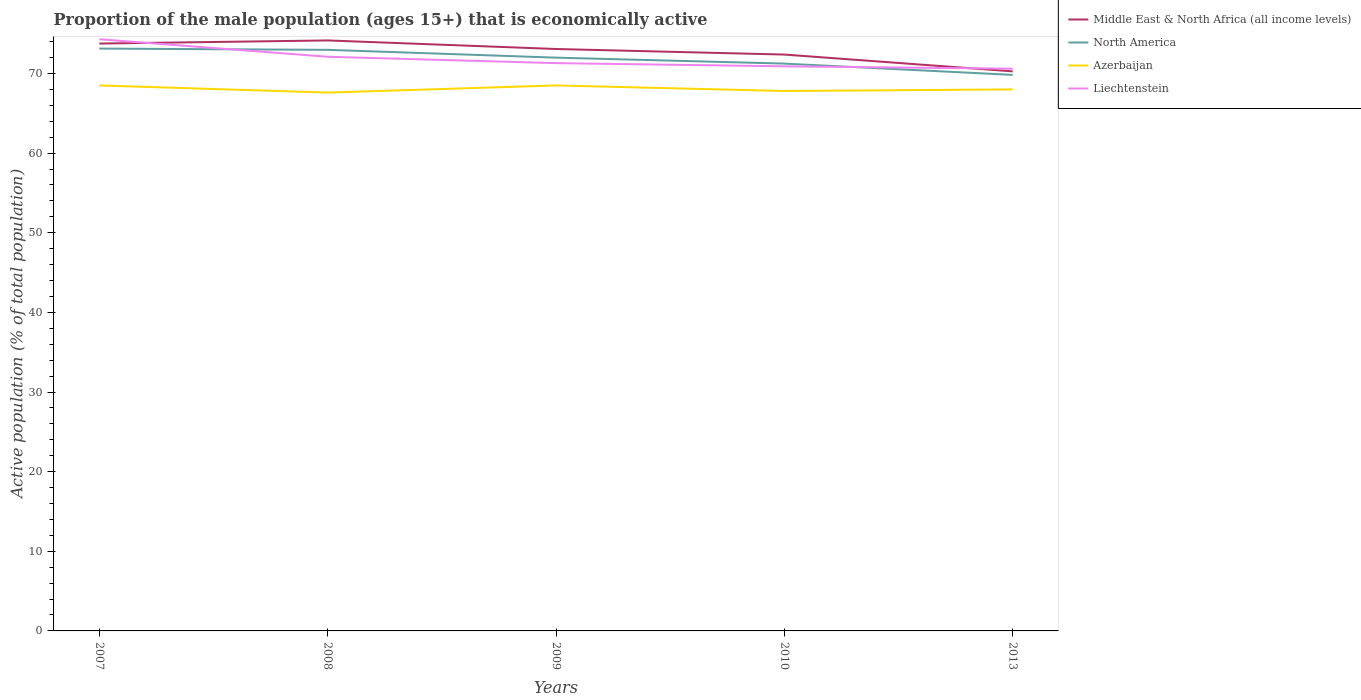Across all years, what is the maximum proportion of the male population that is economically active in Liechtenstein?
Ensure brevity in your answer.  70.6. What is the total proportion of the male population that is economically active in North America in the graph?
Ensure brevity in your answer.  0.75. What is the difference between the highest and the second highest proportion of the male population that is economically active in Liechtenstein?
Offer a terse response. 3.7. How many lines are there?
Provide a succinct answer. 4. How many years are there in the graph?
Provide a short and direct response. 5. Are the values on the major ticks of Y-axis written in scientific E-notation?
Provide a succinct answer. No. Does the graph contain any zero values?
Your answer should be compact. No. Does the graph contain grids?
Your answer should be compact. No. Where does the legend appear in the graph?
Keep it short and to the point. Top right. What is the title of the graph?
Provide a succinct answer. Proportion of the male population (ages 15+) that is economically active. What is the label or title of the X-axis?
Your response must be concise. Years. What is the label or title of the Y-axis?
Offer a very short reply. Active population (% of total population). What is the Active population (% of total population) in Middle East & North Africa (all income levels) in 2007?
Offer a very short reply. 73.76. What is the Active population (% of total population) of North America in 2007?
Give a very brief answer. 73.13. What is the Active population (% of total population) in Azerbaijan in 2007?
Your answer should be compact. 68.5. What is the Active population (% of total population) in Liechtenstein in 2007?
Your answer should be very brief. 74.3. What is the Active population (% of total population) of Middle East & North Africa (all income levels) in 2008?
Keep it short and to the point. 74.15. What is the Active population (% of total population) in North America in 2008?
Keep it short and to the point. 72.97. What is the Active population (% of total population) of Azerbaijan in 2008?
Offer a terse response. 67.6. What is the Active population (% of total population) in Liechtenstein in 2008?
Ensure brevity in your answer.  72.1. What is the Active population (% of total population) of Middle East & North Africa (all income levels) in 2009?
Ensure brevity in your answer.  73.08. What is the Active population (% of total population) of North America in 2009?
Ensure brevity in your answer.  71.99. What is the Active population (% of total population) of Azerbaijan in 2009?
Ensure brevity in your answer.  68.5. What is the Active population (% of total population) of Liechtenstein in 2009?
Keep it short and to the point. 71.3. What is the Active population (% of total population) of Middle East & North Africa (all income levels) in 2010?
Provide a succinct answer. 72.38. What is the Active population (% of total population) in North America in 2010?
Offer a terse response. 71.24. What is the Active population (% of total population) of Azerbaijan in 2010?
Provide a succinct answer. 67.8. What is the Active population (% of total population) in Liechtenstein in 2010?
Ensure brevity in your answer.  70.9. What is the Active population (% of total population) in Middle East & North Africa (all income levels) in 2013?
Keep it short and to the point. 70.27. What is the Active population (% of total population) of North America in 2013?
Keep it short and to the point. 69.82. What is the Active population (% of total population) in Azerbaijan in 2013?
Keep it short and to the point. 68. What is the Active population (% of total population) in Liechtenstein in 2013?
Your response must be concise. 70.6. Across all years, what is the maximum Active population (% of total population) of Middle East & North Africa (all income levels)?
Provide a succinct answer. 74.15. Across all years, what is the maximum Active population (% of total population) in North America?
Ensure brevity in your answer.  73.13. Across all years, what is the maximum Active population (% of total population) of Azerbaijan?
Make the answer very short. 68.5. Across all years, what is the maximum Active population (% of total population) in Liechtenstein?
Offer a terse response. 74.3. Across all years, what is the minimum Active population (% of total population) of Middle East & North Africa (all income levels)?
Provide a succinct answer. 70.27. Across all years, what is the minimum Active population (% of total population) of North America?
Offer a very short reply. 69.82. Across all years, what is the minimum Active population (% of total population) in Azerbaijan?
Your response must be concise. 67.6. Across all years, what is the minimum Active population (% of total population) of Liechtenstein?
Provide a succinct answer. 70.6. What is the total Active population (% of total population) in Middle East & North Africa (all income levels) in the graph?
Your answer should be compact. 363.63. What is the total Active population (% of total population) of North America in the graph?
Provide a short and direct response. 359.15. What is the total Active population (% of total population) of Azerbaijan in the graph?
Provide a succinct answer. 340.4. What is the total Active population (% of total population) of Liechtenstein in the graph?
Your answer should be very brief. 359.2. What is the difference between the Active population (% of total population) of Middle East & North Africa (all income levels) in 2007 and that in 2008?
Your response must be concise. -0.39. What is the difference between the Active population (% of total population) in North America in 2007 and that in 2008?
Provide a succinct answer. 0.16. What is the difference between the Active population (% of total population) in Liechtenstein in 2007 and that in 2008?
Provide a short and direct response. 2.2. What is the difference between the Active population (% of total population) of Middle East & North Africa (all income levels) in 2007 and that in 2009?
Your answer should be compact. 0.68. What is the difference between the Active population (% of total population) of North America in 2007 and that in 2009?
Provide a succinct answer. 1.14. What is the difference between the Active population (% of total population) of Middle East & North Africa (all income levels) in 2007 and that in 2010?
Offer a very short reply. 1.38. What is the difference between the Active population (% of total population) of North America in 2007 and that in 2010?
Your answer should be compact. 1.89. What is the difference between the Active population (% of total population) in Azerbaijan in 2007 and that in 2010?
Provide a short and direct response. 0.7. What is the difference between the Active population (% of total population) of Liechtenstein in 2007 and that in 2010?
Keep it short and to the point. 3.4. What is the difference between the Active population (% of total population) of Middle East & North Africa (all income levels) in 2007 and that in 2013?
Provide a short and direct response. 3.49. What is the difference between the Active population (% of total population) of North America in 2007 and that in 2013?
Offer a terse response. 3.3. What is the difference between the Active population (% of total population) in Middle East & North Africa (all income levels) in 2008 and that in 2009?
Make the answer very short. 1.08. What is the difference between the Active population (% of total population) of North America in 2008 and that in 2009?
Offer a very short reply. 0.98. What is the difference between the Active population (% of total population) in Azerbaijan in 2008 and that in 2009?
Your response must be concise. -0.9. What is the difference between the Active population (% of total population) in Liechtenstein in 2008 and that in 2009?
Give a very brief answer. 0.8. What is the difference between the Active population (% of total population) of Middle East & North Africa (all income levels) in 2008 and that in 2010?
Provide a short and direct response. 1.77. What is the difference between the Active population (% of total population) of North America in 2008 and that in 2010?
Provide a short and direct response. 1.73. What is the difference between the Active population (% of total population) in Azerbaijan in 2008 and that in 2010?
Your answer should be very brief. -0.2. What is the difference between the Active population (% of total population) in Liechtenstein in 2008 and that in 2010?
Offer a terse response. 1.2. What is the difference between the Active population (% of total population) of Middle East & North Africa (all income levels) in 2008 and that in 2013?
Make the answer very short. 3.88. What is the difference between the Active population (% of total population) in North America in 2008 and that in 2013?
Your answer should be very brief. 3.15. What is the difference between the Active population (% of total population) in Azerbaijan in 2008 and that in 2013?
Provide a short and direct response. -0.4. What is the difference between the Active population (% of total population) of Liechtenstein in 2008 and that in 2013?
Offer a terse response. 1.5. What is the difference between the Active population (% of total population) of Middle East & North Africa (all income levels) in 2009 and that in 2010?
Your answer should be compact. 0.7. What is the difference between the Active population (% of total population) in North America in 2009 and that in 2010?
Your answer should be very brief. 0.75. What is the difference between the Active population (% of total population) of Azerbaijan in 2009 and that in 2010?
Offer a terse response. 0.7. What is the difference between the Active population (% of total population) of Liechtenstein in 2009 and that in 2010?
Give a very brief answer. 0.4. What is the difference between the Active population (% of total population) of Middle East & North Africa (all income levels) in 2009 and that in 2013?
Ensure brevity in your answer.  2.81. What is the difference between the Active population (% of total population) of North America in 2009 and that in 2013?
Ensure brevity in your answer.  2.17. What is the difference between the Active population (% of total population) of Azerbaijan in 2009 and that in 2013?
Give a very brief answer. 0.5. What is the difference between the Active population (% of total population) of Middle East & North Africa (all income levels) in 2010 and that in 2013?
Your response must be concise. 2.11. What is the difference between the Active population (% of total population) in North America in 2010 and that in 2013?
Provide a short and direct response. 1.42. What is the difference between the Active population (% of total population) in Middle East & North Africa (all income levels) in 2007 and the Active population (% of total population) in North America in 2008?
Make the answer very short. 0.79. What is the difference between the Active population (% of total population) of Middle East & North Africa (all income levels) in 2007 and the Active population (% of total population) of Azerbaijan in 2008?
Your answer should be very brief. 6.16. What is the difference between the Active population (% of total population) in Middle East & North Africa (all income levels) in 2007 and the Active population (% of total population) in Liechtenstein in 2008?
Your response must be concise. 1.66. What is the difference between the Active population (% of total population) of North America in 2007 and the Active population (% of total population) of Azerbaijan in 2008?
Your response must be concise. 5.53. What is the difference between the Active population (% of total population) in North America in 2007 and the Active population (% of total population) in Liechtenstein in 2008?
Make the answer very short. 1.03. What is the difference between the Active population (% of total population) in Azerbaijan in 2007 and the Active population (% of total population) in Liechtenstein in 2008?
Offer a terse response. -3.6. What is the difference between the Active population (% of total population) in Middle East & North Africa (all income levels) in 2007 and the Active population (% of total population) in North America in 2009?
Provide a short and direct response. 1.77. What is the difference between the Active population (% of total population) in Middle East & North Africa (all income levels) in 2007 and the Active population (% of total population) in Azerbaijan in 2009?
Offer a very short reply. 5.26. What is the difference between the Active population (% of total population) of Middle East & North Africa (all income levels) in 2007 and the Active population (% of total population) of Liechtenstein in 2009?
Your response must be concise. 2.46. What is the difference between the Active population (% of total population) of North America in 2007 and the Active population (% of total population) of Azerbaijan in 2009?
Make the answer very short. 4.63. What is the difference between the Active population (% of total population) of North America in 2007 and the Active population (% of total population) of Liechtenstein in 2009?
Offer a terse response. 1.83. What is the difference between the Active population (% of total population) of Azerbaijan in 2007 and the Active population (% of total population) of Liechtenstein in 2009?
Make the answer very short. -2.8. What is the difference between the Active population (% of total population) of Middle East & North Africa (all income levels) in 2007 and the Active population (% of total population) of North America in 2010?
Offer a very short reply. 2.52. What is the difference between the Active population (% of total population) of Middle East & North Africa (all income levels) in 2007 and the Active population (% of total population) of Azerbaijan in 2010?
Offer a very short reply. 5.96. What is the difference between the Active population (% of total population) of Middle East & North Africa (all income levels) in 2007 and the Active population (% of total population) of Liechtenstein in 2010?
Your answer should be compact. 2.86. What is the difference between the Active population (% of total population) in North America in 2007 and the Active population (% of total population) in Azerbaijan in 2010?
Ensure brevity in your answer.  5.33. What is the difference between the Active population (% of total population) in North America in 2007 and the Active population (% of total population) in Liechtenstein in 2010?
Make the answer very short. 2.23. What is the difference between the Active population (% of total population) in Middle East & North Africa (all income levels) in 2007 and the Active population (% of total population) in North America in 2013?
Keep it short and to the point. 3.94. What is the difference between the Active population (% of total population) in Middle East & North Africa (all income levels) in 2007 and the Active population (% of total population) in Azerbaijan in 2013?
Keep it short and to the point. 5.76. What is the difference between the Active population (% of total population) of Middle East & North Africa (all income levels) in 2007 and the Active population (% of total population) of Liechtenstein in 2013?
Your answer should be very brief. 3.16. What is the difference between the Active population (% of total population) of North America in 2007 and the Active population (% of total population) of Azerbaijan in 2013?
Provide a short and direct response. 5.13. What is the difference between the Active population (% of total population) in North America in 2007 and the Active population (% of total population) in Liechtenstein in 2013?
Offer a very short reply. 2.53. What is the difference between the Active population (% of total population) in Middle East & North Africa (all income levels) in 2008 and the Active population (% of total population) in North America in 2009?
Provide a short and direct response. 2.16. What is the difference between the Active population (% of total population) of Middle East & North Africa (all income levels) in 2008 and the Active population (% of total population) of Azerbaijan in 2009?
Give a very brief answer. 5.65. What is the difference between the Active population (% of total population) in Middle East & North Africa (all income levels) in 2008 and the Active population (% of total population) in Liechtenstein in 2009?
Offer a terse response. 2.85. What is the difference between the Active population (% of total population) of North America in 2008 and the Active population (% of total population) of Azerbaijan in 2009?
Offer a terse response. 4.47. What is the difference between the Active population (% of total population) in North America in 2008 and the Active population (% of total population) in Liechtenstein in 2009?
Offer a terse response. 1.67. What is the difference between the Active population (% of total population) in Middle East & North Africa (all income levels) in 2008 and the Active population (% of total population) in North America in 2010?
Provide a succinct answer. 2.91. What is the difference between the Active population (% of total population) of Middle East & North Africa (all income levels) in 2008 and the Active population (% of total population) of Azerbaijan in 2010?
Give a very brief answer. 6.35. What is the difference between the Active population (% of total population) in Middle East & North Africa (all income levels) in 2008 and the Active population (% of total population) in Liechtenstein in 2010?
Your answer should be compact. 3.25. What is the difference between the Active population (% of total population) of North America in 2008 and the Active population (% of total population) of Azerbaijan in 2010?
Make the answer very short. 5.17. What is the difference between the Active population (% of total population) in North America in 2008 and the Active population (% of total population) in Liechtenstein in 2010?
Give a very brief answer. 2.07. What is the difference between the Active population (% of total population) of Middle East & North Africa (all income levels) in 2008 and the Active population (% of total population) of North America in 2013?
Your answer should be compact. 4.33. What is the difference between the Active population (% of total population) in Middle East & North Africa (all income levels) in 2008 and the Active population (% of total population) in Azerbaijan in 2013?
Ensure brevity in your answer.  6.15. What is the difference between the Active population (% of total population) of Middle East & North Africa (all income levels) in 2008 and the Active population (% of total population) of Liechtenstein in 2013?
Give a very brief answer. 3.55. What is the difference between the Active population (% of total population) in North America in 2008 and the Active population (% of total population) in Azerbaijan in 2013?
Make the answer very short. 4.97. What is the difference between the Active population (% of total population) in North America in 2008 and the Active population (% of total population) in Liechtenstein in 2013?
Your answer should be compact. 2.37. What is the difference between the Active population (% of total population) of Azerbaijan in 2008 and the Active population (% of total population) of Liechtenstein in 2013?
Make the answer very short. -3. What is the difference between the Active population (% of total population) of Middle East & North Africa (all income levels) in 2009 and the Active population (% of total population) of North America in 2010?
Make the answer very short. 1.83. What is the difference between the Active population (% of total population) in Middle East & North Africa (all income levels) in 2009 and the Active population (% of total population) in Azerbaijan in 2010?
Your response must be concise. 5.28. What is the difference between the Active population (% of total population) in Middle East & North Africa (all income levels) in 2009 and the Active population (% of total population) in Liechtenstein in 2010?
Offer a terse response. 2.18. What is the difference between the Active population (% of total population) of North America in 2009 and the Active population (% of total population) of Azerbaijan in 2010?
Make the answer very short. 4.19. What is the difference between the Active population (% of total population) of North America in 2009 and the Active population (% of total population) of Liechtenstein in 2010?
Your answer should be compact. 1.09. What is the difference between the Active population (% of total population) in Azerbaijan in 2009 and the Active population (% of total population) in Liechtenstein in 2010?
Your answer should be very brief. -2.4. What is the difference between the Active population (% of total population) of Middle East & North Africa (all income levels) in 2009 and the Active population (% of total population) of North America in 2013?
Provide a succinct answer. 3.25. What is the difference between the Active population (% of total population) in Middle East & North Africa (all income levels) in 2009 and the Active population (% of total population) in Azerbaijan in 2013?
Keep it short and to the point. 5.08. What is the difference between the Active population (% of total population) of Middle East & North Africa (all income levels) in 2009 and the Active population (% of total population) of Liechtenstein in 2013?
Your answer should be compact. 2.48. What is the difference between the Active population (% of total population) in North America in 2009 and the Active population (% of total population) in Azerbaijan in 2013?
Provide a succinct answer. 3.99. What is the difference between the Active population (% of total population) in North America in 2009 and the Active population (% of total population) in Liechtenstein in 2013?
Provide a short and direct response. 1.39. What is the difference between the Active population (% of total population) in Azerbaijan in 2009 and the Active population (% of total population) in Liechtenstein in 2013?
Your answer should be compact. -2.1. What is the difference between the Active population (% of total population) of Middle East & North Africa (all income levels) in 2010 and the Active population (% of total population) of North America in 2013?
Give a very brief answer. 2.55. What is the difference between the Active population (% of total population) in Middle East & North Africa (all income levels) in 2010 and the Active population (% of total population) in Azerbaijan in 2013?
Your response must be concise. 4.38. What is the difference between the Active population (% of total population) in Middle East & North Africa (all income levels) in 2010 and the Active population (% of total population) in Liechtenstein in 2013?
Ensure brevity in your answer.  1.78. What is the difference between the Active population (% of total population) of North America in 2010 and the Active population (% of total population) of Azerbaijan in 2013?
Make the answer very short. 3.24. What is the difference between the Active population (% of total population) of North America in 2010 and the Active population (% of total population) of Liechtenstein in 2013?
Provide a short and direct response. 0.64. What is the difference between the Active population (% of total population) of Azerbaijan in 2010 and the Active population (% of total population) of Liechtenstein in 2013?
Your answer should be very brief. -2.8. What is the average Active population (% of total population) in Middle East & North Africa (all income levels) per year?
Give a very brief answer. 72.73. What is the average Active population (% of total population) in North America per year?
Provide a succinct answer. 71.83. What is the average Active population (% of total population) in Azerbaijan per year?
Keep it short and to the point. 68.08. What is the average Active population (% of total population) of Liechtenstein per year?
Your answer should be very brief. 71.84. In the year 2007, what is the difference between the Active population (% of total population) in Middle East & North Africa (all income levels) and Active population (% of total population) in North America?
Offer a very short reply. 0.63. In the year 2007, what is the difference between the Active population (% of total population) in Middle East & North Africa (all income levels) and Active population (% of total population) in Azerbaijan?
Provide a short and direct response. 5.26. In the year 2007, what is the difference between the Active population (% of total population) in Middle East & North Africa (all income levels) and Active population (% of total population) in Liechtenstein?
Your answer should be compact. -0.54. In the year 2007, what is the difference between the Active population (% of total population) of North America and Active population (% of total population) of Azerbaijan?
Your answer should be compact. 4.63. In the year 2007, what is the difference between the Active population (% of total population) in North America and Active population (% of total population) in Liechtenstein?
Your answer should be very brief. -1.17. In the year 2007, what is the difference between the Active population (% of total population) in Azerbaijan and Active population (% of total population) in Liechtenstein?
Give a very brief answer. -5.8. In the year 2008, what is the difference between the Active population (% of total population) in Middle East & North Africa (all income levels) and Active population (% of total population) in North America?
Offer a terse response. 1.18. In the year 2008, what is the difference between the Active population (% of total population) in Middle East & North Africa (all income levels) and Active population (% of total population) in Azerbaijan?
Your answer should be compact. 6.55. In the year 2008, what is the difference between the Active population (% of total population) in Middle East & North Africa (all income levels) and Active population (% of total population) in Liechtenstein?
Make the answer very short. 2.05. In the year 2008, what is the difference between the Active population (% of total population) in North America and Active population (% of total population) in Azerbaijan?
Keep it short and to the point. 5.37. In the year 2008, what is the difference between the Active population (% of total population) in North America and Active population (% of total population) in Liechtenstein?
Your answer should be compact. 0.87. In the year 2009, what is the difference between the Active population (% of total population) of Middle East & North Africa (all income levels) and Active population (% of total population) of North America?
Keep it short and to the point. 1.09. In the year 2009, what is the difference between the Active population (% of total population) of Middle East & North Africa (all income levels) and Active population (% of total population) of Azerbaijan?
Your answer should be very brief. 4.58. In the year 2009, what is the difference between the Active population (% of total population) of Middle East & North Africa (all income levels) and Active population (% of total population) of Liechtenstein?
Provide a succinct answer. 1.78. In the year 2009, what is the difference between the Active population (% of total population) of North America and Active population (% of total population) of Azerbaijan?
Provide a succinct answer. 3.49. In the year 2009, what is the difference between the Active population (% of total population) in North America and Active population (% of total population) in Liechtenstein?
Provide a short and direct response. 0.69. In the year 2010, what is the difference between the Active population (% of total population) of Middle East & North Africa (all income levels) and Active population (% of total population) of North America?
Your answer should be compact. 1.14. In the year 2010, what is the difference between the Active population (% of total population) of Middle East & North Africa (all income levels) and Active population (% of total population) of Azerbaijan?
Give a very brief answer. 4.58. In the year 2010, what is the difference between the Active population (% of total population) in Middle East & North Africa (all income levels) and Active population (% of total population) in Liechtenstein?
Your response must be concise. 1.48. In the year 2010, what is the difference between the Active population (% of total population) of North America and Active population (% of total population) of Azerbaijan?
Your response must be concise. 3.44. In the year 2010, what is the difference between the Active population (% of total population) of North America and Active population (% of total population) of Liechtenstein?
Ensure brevity in your answer.  0.34. In the year 2013, what is the difference between the Active population (% of total population) of Middle East & North Africa (all income levels) and Active population (% of total population) of North America?
Provide a succinct answer. 0.44. In the year 2013, what is the difference between the Active population (% of total population) of Middle East & North Africa (all income levels) and Active population (% of total population) of Azerbaijan?
Your response must be concise. 2.27. In the year 2013, what is the difference between the Active population (% of total population) in Middle East & North Africa (all income levels) and Active population (% of total population) in Liechtenstein?
Ensure brevity in your answer.  -0.33. In the year 2013, what is the difference between the Active population (% of total population) of North America and Active population (% of total population) of Azerbaijan?
Keep it short and to the point. 1.82. In the year 2013, what is the difference between the Active population (% of total population) in North America and Active population (% of total population) in Liechtenstein?
Your answer should be very brief. -0.78. What is the ratio of the Active population (% of total population) in Azerbaijan in 2007 to that in 2008?
Provide a short and direct response. 1.01. What is the ratio of the Active population (% of total population) of Liechtenstein in 2007 to that in 2008?
Provide a succinct answer. 1.03. What is the ratio of the Active population (% of total population) in Middle East & North Africa (all income levels) in 2007 to that in 2009?
Offer a very short reply. 1.01. What is the ratio of the Active population (% of total population) in North America in 2007 to that in 2009?
Offer a terse response. 1.02. What is the ratio of the Active population (% of total population) in Azerbaijan in 2007 to that in 2009?
Provide a succinct answer. 1. What is the ratio of the Active population (% of total population) of Liechtenstein in 2007 to that in 2009?
Offer a very short reply. 1.04. What is the ratio of the Active population (% of total population) of Middle East & North Africa (all income levels) in 2007 to that in 2010?
Your response must be concise. 1.02. What is the ratio of the Active population (% of total population) of North America in 2007 to that in 2010?
Your answer should be very brief. 1.03. What is the ratio of the Active population (% of total population) in Azerbaijan in 2007 to that in 2010?
Ensure brevity in your answer.  1.01. What is the ratio of the Active population (% of total population) of Liechtenstein in 2007 to that in 2010?
Ensure brevity in your answer.  1.05. What is the ratio of the Active population (% of total population) of Middle East & North Africa (all income levels) in 2007 to that in 2013?
Your response must be concise. 1.05. What is the ratio of the Active population (% of total population) of North America in 2007 to that in 2013?
Your answer should be compact. 1.05. What is the ratio of the Active population (% of total population) in Azerbaijan in 2007 to that in 2013?
Keep it short and to the point. 1.01. What is the ratio of the Active population (% of total population) in Liechtenstein in 2007 to that in 2013?
Provide a short and direct response. 1.05. What is the ratio of the Active population (% of total population) of Middle East & North Africa (all income levels) in 2008 to that in 2009?
Your response must be concise. 1.01. What is the ratio of the Active population (% of total population) of North America in 2008 to that in 2009?
Your response must be concise. 1.01. What is the ratio of the Active population (% of total population) of Azerbaijan in 2008 to that in 2009?
Keep it short and to the point. 0.99. What is the ratio of the Active population (% of total population) in Liechtenstein in 2008 to that in 2009?
Make the answer very short. 1.01. What is the ratio of the Active population (% of total population) of Middle East & North Africa (all income levels) in 2008 to that in 2010?
Keep it short and to the point. 1.02. What is the ratio of the Active population (% of total population) in North America in 2008 to that in 2010?
Make the answer very short. 1.02. What is the ratio of the Active population (% of total population) of Liechtenstein in 2008 to that in 2010?
Give a very brief answer. 1.02. What is the ratio of the Active population (% of total population) in Middle East & North Africa (all income levels) in 2008 to that in 2013?
Offer a very short reply. 1.06. What is the ratio of the Active population (% of total population) in North America in 2008 to that in 2013?
Give a very brief answer. 1.04. What is the ratio of the Active population (% of total population) in Liechtenstein in 2008 to that in 2013?
Give a very brief answer. 1.02. What is the ratio of the Active population (% of total population) of Middle East & North Africa (all income levels) in 2009 to that in 2010?
Make the answer very short. 1.01. What is the ratio of the Active population (% of total population) in North America in 2009 to that in 2010?
Your answer should be compact. 1.01. What is the ratio of the Active population (% of total population) of Azerbaijan in 2009 to that in 2010?
Your answer should be very brief. 1.01. What is the ratio of the Active population (% of total population) of Liechtenstein in 2009 to that in 2010?
Offer a terse response. 1.01. What is the ratio of the Active population (% of total population) in North America in 2009 to that in 2013?
Provide a succinct answer. 1.03. What is the ratio of the Active population (% of total population) in Azerbaijan in 2009 to that in 2013?
Your answer should be compact. 1.01. What is the ratio of the Active population (% of total population) in Liechtenstein in 2009 to that in 2013?
Provide a succinct answer. 1.01. What is the ratio of the Active population (% of total population) of Middle East & North Africa (all income levels) in 2010 to that in 2013?
Ensure brevity in your answer.  1.03. What is the ratio of the Active population (% of total population) in North America in 2010 to that in 2013?
Your response must be concise. 1.02. What is the ratio of the Active population (% of total population) in Azerbaijan in 2010 to that in 2013?
Provide a succinct answer. 1. What is the ratio of the Active population (% of total population) of Liechtenstein in 2010 to that in 2013?
Provide a succinct answer. 1. What is the difference between the highest and the second highest Active population (% of total population) of Middle East & North Africa (all income levels)?
Your response must be concise. 0.39. What is the difference between the highest and the second highest Active population (% of total population) in North America?
Give a very brief answer. 0.16. What is the difference between the highest and the second highest Active population (% of total population) in Azerbaijan?
Your answer should be very brief. 0. What is the difference between the highest and the second highest Active population (% of total population) of Liechtenstein?
Ensure brevity in your answer.  2.2. What is the difference between the highest and the lowest Active population (% of total population) in Middle East & North Africa (all income levels)?
Provide a short and direct response. 3.88. What is the difference between the highest and the lowest Active population (% of total population) in North America?
Keep it short and to the point. 3.3. What is the difference between the highest and the lowest Active population (% of total population) in Azerbaijan?
Offer a terse response. 0.9. What is the difference between the highest and the lowest Active population (% of total population) of Liechtenstein?
Offer a very short reply. 3.7. 